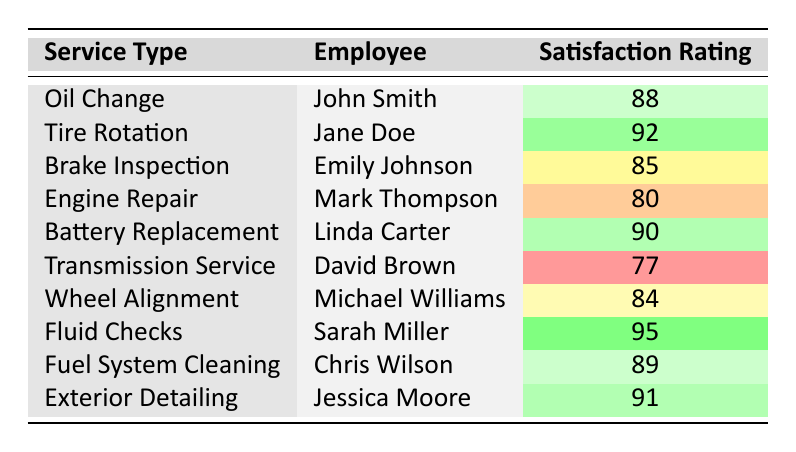What is the satisfaction rating for Tire Rotation? The table directly states that for the service type "Tire Rotation," the satisfaction rating is 92, as indicated by the corresponding row.
Answer: 92 Who received the highest satisfaction rating and what was it? By inspecting the table, we find that "Fluid Checks" provided by Sarah Miller holds the highest satisfaction rating of 95.
Answer: Sarah Miller, 95 Is the satisfaction rating for Engine Repair above 75? The rating for "Engine Repair" is listed as 80, which is above 75, so this statement is true based on the data provided in the table.
Answer: Yes What is the average satisfaction rating for all services listed? To find the average, we sum all the satisfaction ratings: (88 + 92 + 85 + 80 + 90 + 77 + 84 + 95 + 89 + 91) = 900. Dividing by the total number of services (10), 900/10 results in an average of 90.
Answer: 90 Which employee has the lowest satisfaction rating and what was the rating? The table shows that the employee with the lowest satisfaction rating is David Brown for "Transmission Service," with a rating of 77.
Answer: David Brown, 77 Was there any employee who received a satisfaction rating of 85 or higher? By reviewing the table, we can see multiple ratings are above or at 85. Employees such as John Smith, Jane Doe, and others have ratings that meet this criterion. Therefore, the answer is yes.
Answer: Yes How many employees have satisfaction ratings below 85? From the table, we identify two employees with ratings below 85: David Brown (77) and Mark Thompson (80). To get the count, we see that there are two such cases.
Answer: 2 What is the difference between the highest and lowest satisfaction ratings? The highest satisfaction rating is 95 (Sarah Miller for Fluid Checks) and the lowest is 77 (David Brown for Transmission Service). The difference is calculated as 95 - 77 = 18.
Answer: 18 Which service type had a satisfaction rating closest to 90? By examining the ratings, we observe that the ratings for Battery Replacement (90) and Exterior Detailing (91) are both very close to 90. However, since 90 is exact for one service, we conclude it’s the closest.
Answer: Battery Replacement, 90 